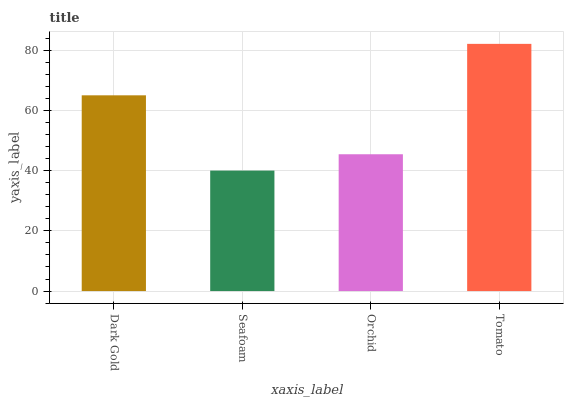Is Orchid the minimum?
Answer yes or no. No. Is Orchid the maximum?
Answer yes or no. No. Is Orchid greater than Seafoam?
Answer yes or no. Yes. Is Seafoam less than Orchid?
Answer yes or no. Yes. Is Seafoam greater than Orchid?
Answer yes or no. No. Is Orchid less than Seafoam?
Answer yes or no. No. Is Dark Gold the high median?
Answer yes or no. Yes. Is Orchid the low median?
Answer yes or no. Yes. Is Orchid the high median?
Answer yes or no. No. Is Tomato the low median?
Answer yes or no. No. 